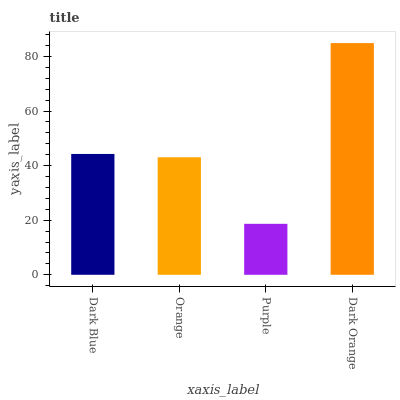Is Purple the minimum?
Answer yes or no. Yes. Is Dark Orange the maximum?
Answer yes or no. Yes. Is Orange the minimum?
Answer yes or no. No. Is Orange the maximum?
Answer yes or no. No. Is Dark Blue greater than Orange?
Answer yes or no. Yes. Is Orange less than Dark Blue?
Answer yes or no. Yes. Is Orange greater than Dark Blue?
Answer yes or no. No. Is Dark Blue less than Orange?
Answer yes or no. No. Is Dark Blue the high median?
Answer yes or no. Yes. Is Orange the low median?
Answer yes or no. Yes. Is Orange the high median?
Answer yes or no. No. Is Purple the low median?
Answer yes or no. No. 